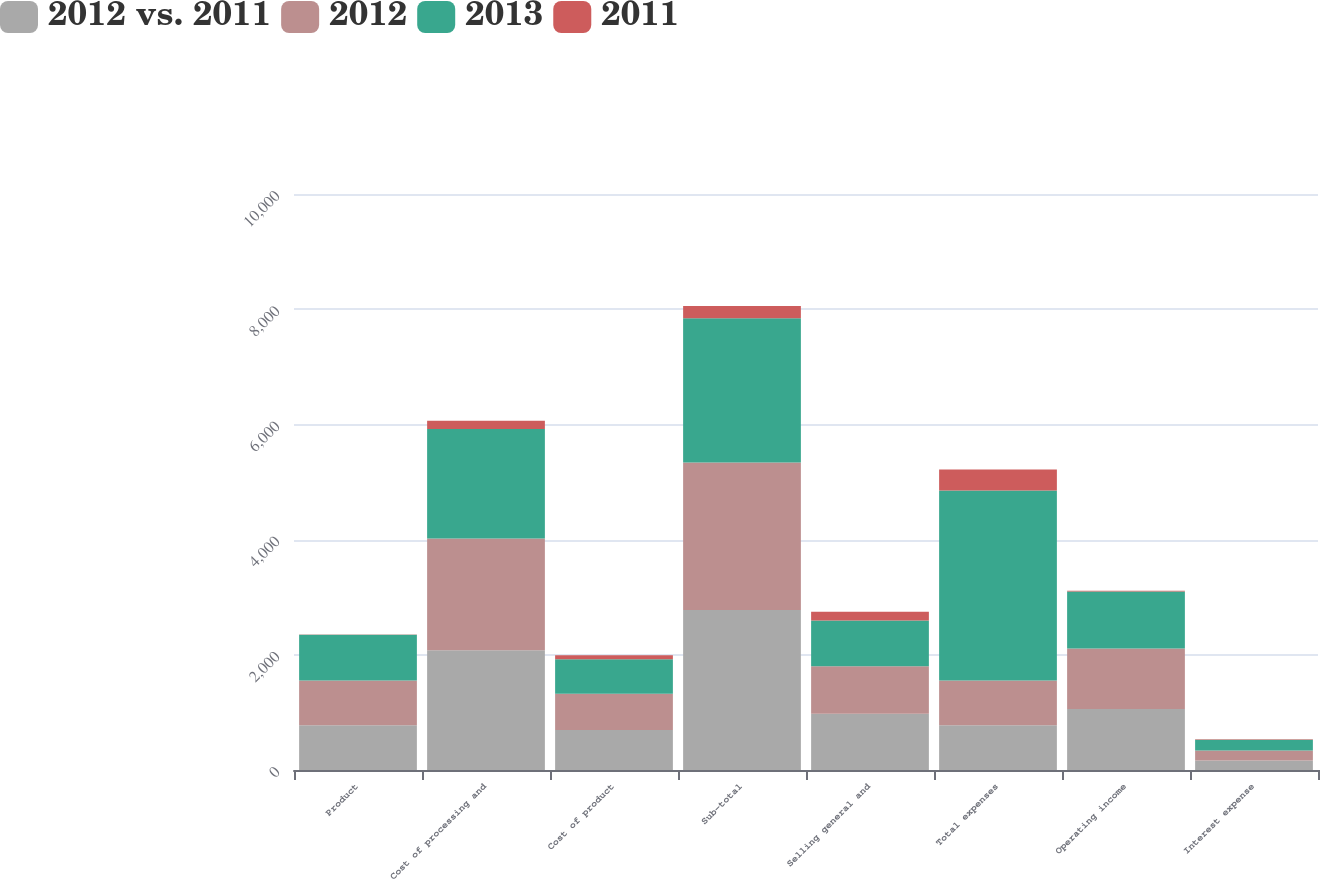Convert chart to OTSL. <chart><loc_0><loc_0><loc_500><loc_500><stacked_bar_chart><ecel><fcel>Product<fcel>Cost of processing and<fcel>Cost of product<fcel>Sub-total<fcel>Selling general and<fcel>Total expenses<fcel>Operating income<fcel>Interest expense<nl><fcel>2012 vs. 2011<fcel>779<fcel>2081<fcel>695<fcel>2776<fcel>977<fcel>776<fcel>1061<fcel>164<nl><fcel>2012<fcel>773<fcel>1936<fcel>628<fcel>2564<fcel>824<fcel>776<fcel>1048<fcel>174<nl><fcel>2013<fcel>794<fcel>1903<fcel>601<fcel>2504<fcel>795<fcel>3299<fcel>990<fcel>188<nl><fcel>2011<fcel>6<fcel>145<fcel>67<fcel>212<fcel>153<fcel>365<fcel>13<fcel>10<nl></chart> 